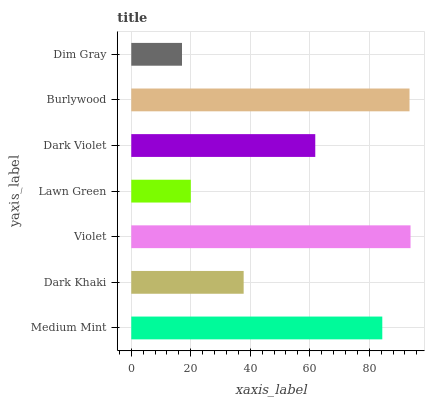Is Dim Gray the minimum?
Answer yes or no. Yes. Is Violet the maximum?
Answer yes or no. Yes. Is Dark Khaki the minimum?
Answer yes or no. No. Is Dark Khaki the maximum?
Answer yes or no. No. Is Medium Mint greater than Dark Khaki?
Answer yes or no. Yes. Is Dark Khaki less than Medium Mint?
Answer yes or no. Yes. Is Dark Khaki greater than Medium Mint?
Answer yes or no. No. Is Medium Mint less than Dark Khaki?
Answer yes or no. No. Is Dark Violet the high median?
Answer yes or no. Yes. Is Dark Violet the low median?
Answer yes or no. Yes. Is Medium Mint the high median?
Answer yes or no. No. Is Dark Khaki the low median?
Answer yes or no. No. 